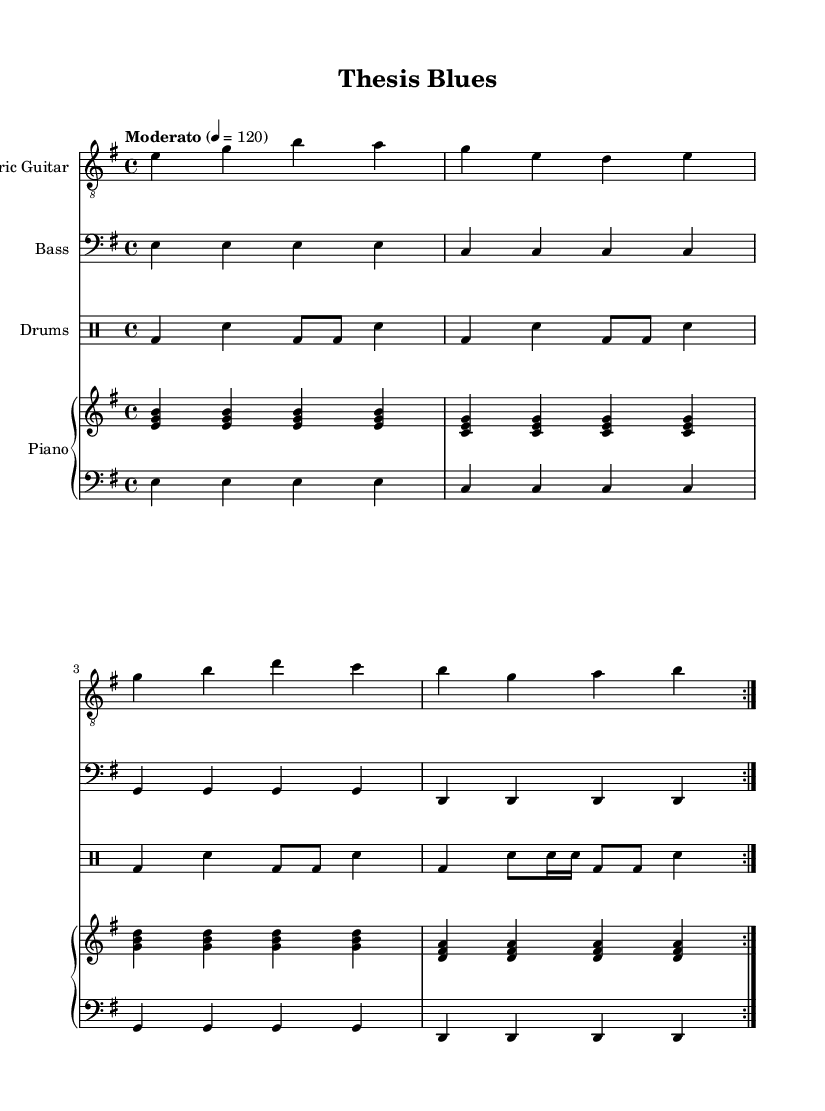What is the key signature of this music? The key signature is E minor, which has one sharp (F#) in its scale. This can be deduced from the title indicating the key section and by identifying the notes within the score that correspond to the E minor scale.
Answer: E minor What is the time signature of this music? The time signature is 4/4, which is indicated at the start of the score. Each measure is divided into four beats, which can be observed in the rhythmic organization of the notes throughout the piece.
Answer: 4/4 What is the tempo marking of the piece? The tempo marking is "Moderato," which denotes a moderate speed for the performance. This is noted prominently at the beginning of the score.
Answer: Moderato How many sections does the main electric guitar part repeat? The main electric guitar part repeats twice, which is indicated by the "volta 2" notation in the score. This shows that the specified measures will be performed twice before moving on.
Answer: 2 What is the primary theme of this piece? The primary theme revolves around academic pressure and self-discovery, as indicated by the title "Thesis Blues" and the context of the music, which suggests a introspective emotional journey typical of alternative rock.
Answer: Academic pressure and self-discovery How many beats does the bass guitar play in one measure? The bass guitar plays four beats in each measure, corresponding to the 4/4 time signature. Each note in the bass part is a quarter note, highlighting the consistent timing throughout the music.
Answer: 4 What type of accompaniment does the piano provide? The piano provides both the right-hand melody and left-hand harmony, playing chords while maintaining a steady bass line, which is typical of the rock genre to support the main melody.
Answer: Chords and bass line 